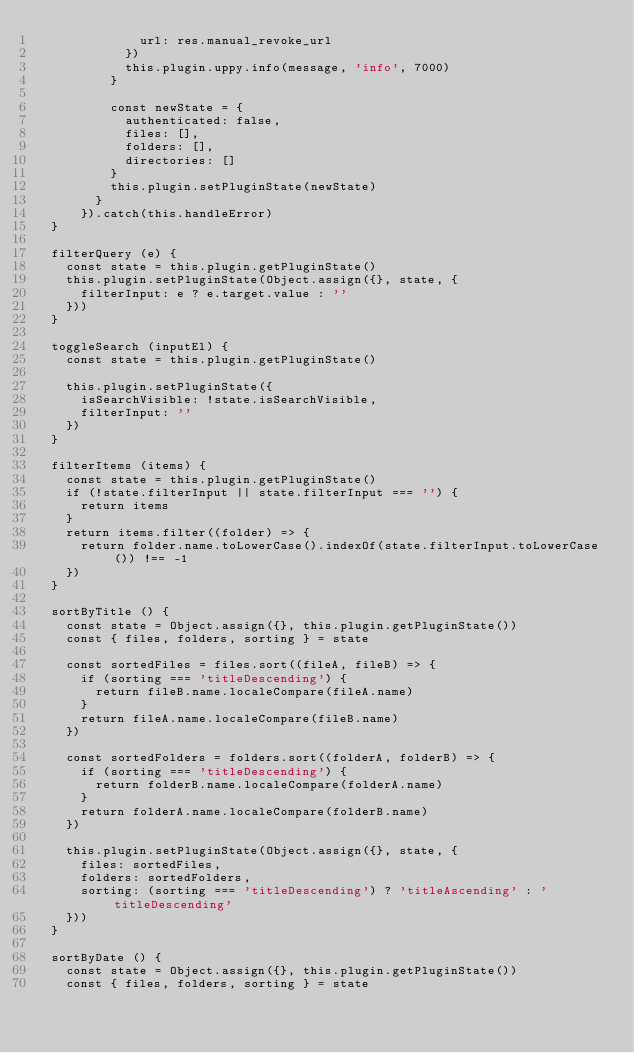Convert code to text. <code><loc_0><loc_0><loc_500><loc_500><_JavaScript_>              url: res.manual_revoke_url
            })
            this.plugin.uppy.info(message, 'info', 7000)
          }

          const newState = {
            authenticated: false,
            files: [],
            folders: [],
            directories: []
          }
          this.plugin.setPluginState(newState)
        }
      }).catch(this.handleError)
  }

  filterQuery (e) {
    const state = this.plugin.getPluginState()
    this.plugin.setPluginState(Object.assign({}, state, {
      filterInput: e ? e.target.value : ''
    }))
  }

  toggleSearch (inputEl) {
    const state = this.plugin.getPluginState()

    this.plugin.setPluginState({
      isSearchVisible: !state.isSearchVisible,
      filterInput: ''
    })
  }

  filterItems (items) {
    const state = this.plugin.getPluginState()
    if (!state.filterInput || state.filterInput === '') {
      return items
    }
    return items.filter((folder) => {
      return folder.name.toLowerCase().indexOf(state.filterInput.toLowerCase()) !== -1
    })
  }

  sortByTitle () {
    const state = Object.assign({}, this.plugin.getPluginState())
    const { files, folders, sorting } = state

    const sortedFiles = files.sort((fileA, fileB) => {
      if (sorting === 'titleDescending') {
        return fileB.name.localeCompare(fileA.name)
      }
      return fileA.name.localeCompare(fileB.name)
    })

    const sortedFolders = folders.sort((folderA, folderB) => {
      if (sorting === 'titleDescending') {
        return folderB.name.localeCompare(folderA.name)
      }
      return folderA.name.localeCompare(folderB.name)
    })

    this.plugin.setPluginState(Object.assign({}, state, {
      files: sortedFiles,
      folders: sortedFolders,
      sorting: (sorting === 'titleDescending') ? 'titleAscending' : 'titleDescending'
    }))
  }

  sortByDate () {
    const state = Object.assign({}, this.plugin.getPluginState())
    const { files, folders, sorting } = state
</code> 